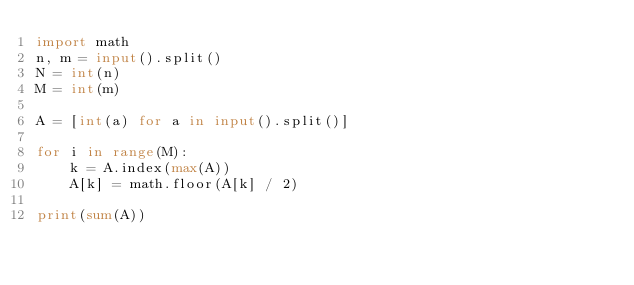Convert code to text. <code><loc_0><loc_0><loc_500><loc_500><_Python_>import math
n, m = input().split()
N = int(n)
M = int(m)

A = [int(a) for a in input().split()]

for i in range(M):
    k = A.index(max(A))
    A[k] = math.floor(A[k] / 2)

print(sum(A))</code> 